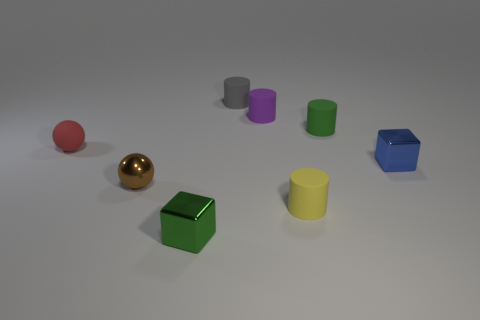Are there any red cylinders of the same size as the green cube?
Provide a succinct answer. No. What is the shape of the tiny red rubber thing?
Provide a succinct answer. Sphere. How many cylinders are either purple rubber objects or tiny objects?
Make the answer very short. 4. Are there the same number of tiny green cylinders that are behind the purple matte cylinder and things in front of the small red sphere?
Offer a terse response. No. There is a small metallic block behind the small metal cube that is left of the gray rubber object; what number of shiny cubes are left of it?
Your response must be concise. 1. Are there more small metallic things that are left of the small green matte object than small matte balls?
Provide a short and direct response. Yes. What number of objects are either green objects in front of the small matte ball or small cylinders that are on the right side of the tiny purple object?
Offer a terse response. 3. Is the shape of the small rubber object behind the tiny purple rubber cylinder the same as  the small red thing?
Your answer should be very brief. No. How many red things are either shiny balls or shiny blocks?
Make the answer very short. 0. How many other objects are there of the same shape as the purple thing?
Give a very brief answer. 3. 